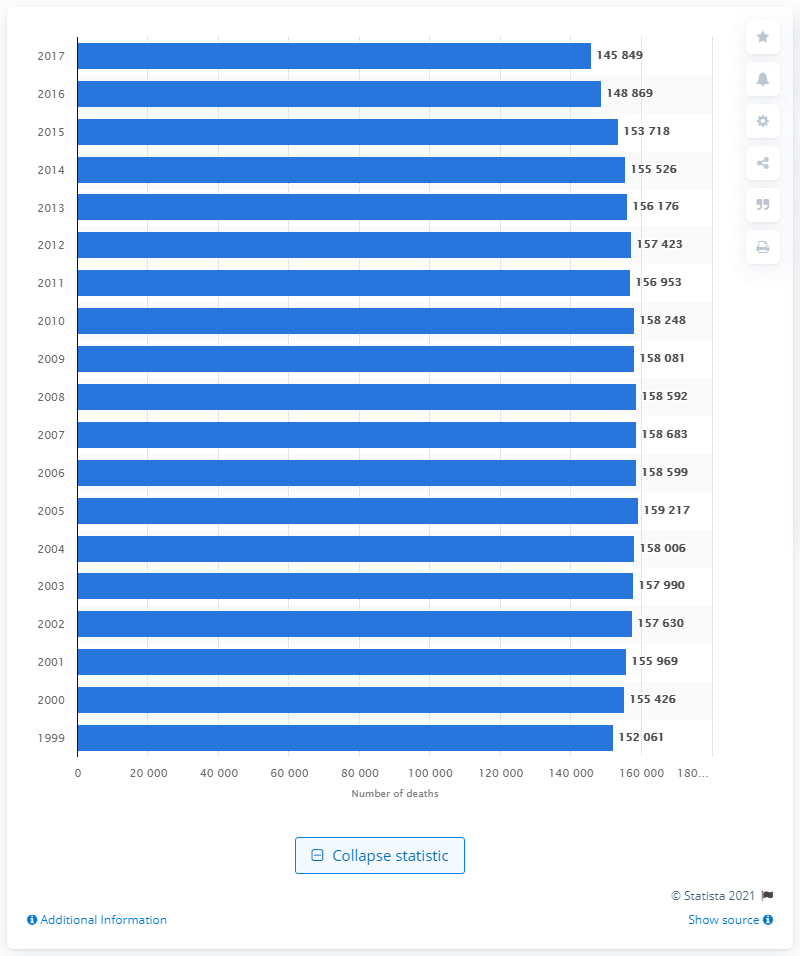Highlight a few significant elements in this photo. In the year 2005, the highest number of deaths due to lung and bronchus cancer was reported. 